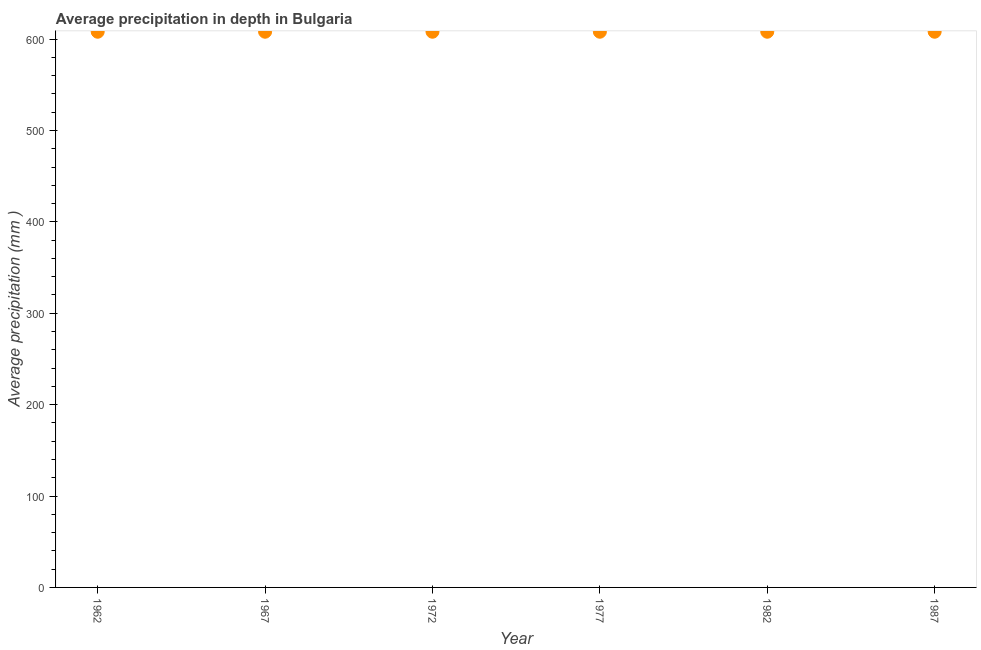What is the average precipitation in depth in 1987?
Give a very brief answer. 608. Across all years, what is the maximum average precipitation in depth?
Make the answer very short. 608. Across all years, what is the minimum average precipitation in depth?
Ensure brevity in your answer.  608. In which year was the average precipitation in depth maximum?
Offer a terse response. 1962. In which year was the average precipitation in depth minimum?
Make the answer very short. 1962. What is the sum of the average precipitation in depth?
Ensure brevity in your answer.  3648. What is the difference between the average precipitation in depth in 1962 and 1987?
Offer a terse response. 0. What is the average average precipitation in depth per year?
Ensure brevity in your answer.  608. What is the median average precipitation in depth?
Provide a succinct answer. 608. In how many years, is the average precipitation in depth greater than 540 mm?
Provide a short and direct response. 6. What is the ratio of the average precipitation in depth in 1967 to that in 1977?
Make the answer very short. 1. Is the average precipitation in depth in 1967 less than that in 1972?
Ensure brevity in your answer.  No. What is the difference between the highest and the second highest average precipitation in depth?
Your response must be concise. 0. What is the difference between the highest and the lowest average precipitation in depth?
Make the answer very short. 0. In how many years, is the average precipitation in depth greater than the average average precipitation in depth taken over all years?
Provide a short and direct response. 0. Does the average precipitation in depth monotonically increase over the years?
Provide a short and direct response. No. How many dotlines are there?
Keep it short and to the point. 1. What is the difference between two consecutive major ticks on the Y-axis?
Your answer should be compact. 100. Are the values on the major ticks of Y-axis written in scientific E-notation?
Ensure brevity in your answer.  No. Does the graph contain grids?
Provide a succinct answer. No. What is the title of the graph?
Keep it short and to the point. Average precipitation in depth in Bulgaria. What is the label or title of the Y-axis?
Keep it short and to the point. Average precipitation (mm ). What is the Average precipitation (mm ) in 1962?
Offer a very short reply. 608. What is the Average precipitation (mm ) in 1967?
Ensure brevity in your answer.  608. What is the Average precipitation (mm ) in 1972?
Your answer should be very brief. 608. What is the Average precipitation (mm ) in 1977?
Provide a short and direct response. 608. What is the Average precipitation (mm ) in 1982?
Provide a short and direct response. 608. What is the Average precipitation (mm ) in 1987?
Provide a succinct answer. 608. What is the difference between the Average precipitation (mm ) in 1962 and 1967?
Your response must be concise. 0. What is the difference between the Average precipitation (mm ) in 1962 and 1972?
Offer a terse response. 0. What is the difference between the Average precipitation (mm ) in 1962 and 1977?
Your answer should be compact. 0. What is the difference between the Average precipitation (mm ) in 1962 and 1987?
Offer a terse response. 0. What is the difference between the Average precipitation (mm ) in 1967 and 1982?
Keep it short and to the point. 0. What is the difference between the Average precipitation (mm ) in 1967 and 1987?
Ensure brevity in your answer.  0. What is the difference between the Average precipitation (mm ) in 1972 and 1977?
Your answer should be compact. 0. What is the difference between the Average precipitation (mm ) in 1972 and 1987?
Your answer should be very brief. 0. What is the difference between the Average precipitation (mm ) in 1977 and 1987?
Offer a terse response. 0. What is the difference between the Average precipitation (mm ) in 1982 and 1987?
Provide a succinct answer. 0. What is the ratio of the Average precipitation (mm ) in 1962 to that in 1967?
Make the answer very short. 1. What is the ratio of the Average precipitation (mm ) in 1962 to that in 1987?
Your response must be concise. 1. What is the ratio of the Average precipitation (mm ) in 1967 to that in 1977?
Give a very brief answer. 1. What is the ratio of the Average precipitation (mm ) in 1967 to that in 1987?
Give a very brief answer. 1. What is the ratio of the Average precipitation (mm ) in 1972 to that in 1982?
Provide a succinct answer. 1. What is the ratio of the Average precipitation (mm ) in 1977 to that in 1987?
Ensure brevity in your answer.  1. 